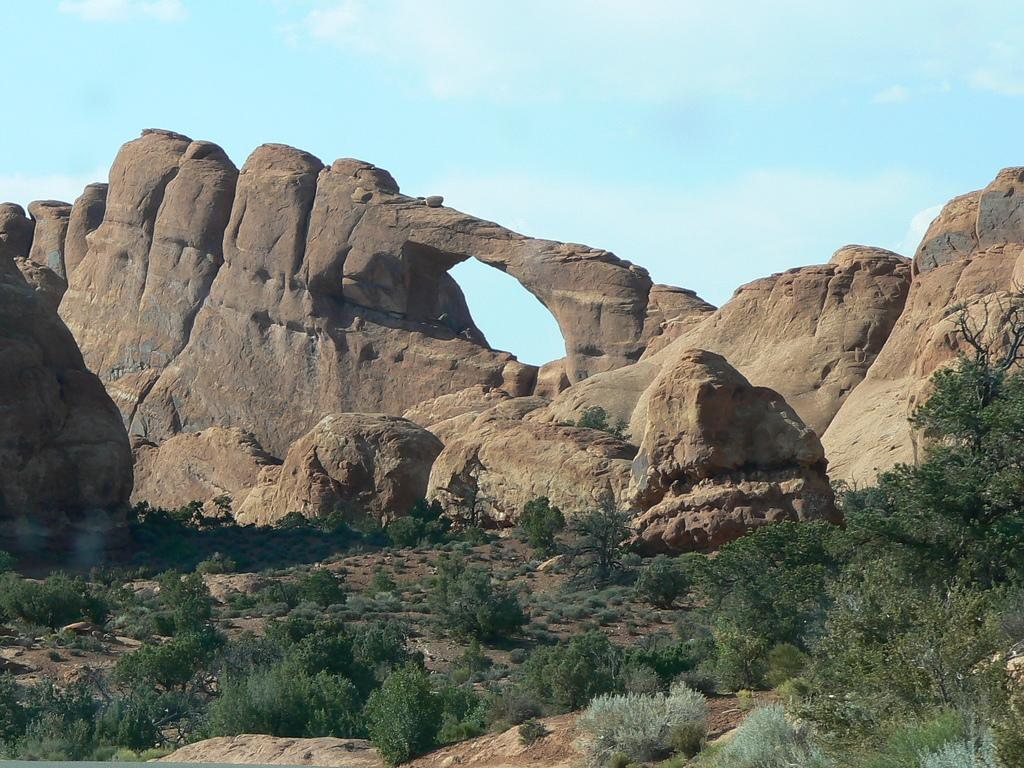What location is depicted in the image? The image appears to depict Arches National Park. What type of natural features can be seen in the image? There are rocks, trees, bushes, and plants visible in the image. What is on the ground in the image? Grass is on the ground in the image. What is visible at the top of the image? The sky is visible at the top of the image. What type of corn is growing in the image? There is no corn present in the image; it depicts Arches National Park with natural features such as rocks, trees, bushes, and plants. 